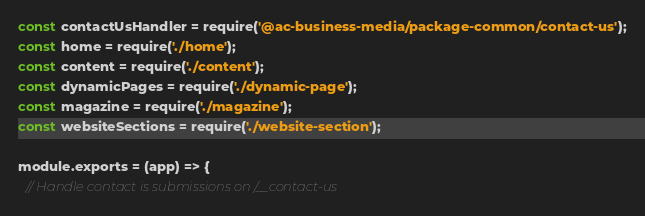<code> <loc_0><loc_0><loc_500><loc_500><_JavaScript_>const contactUsHandler = require('@ac-business-media/package-common/contact-us');
const home = require('./home');
const content = require('./content');
const dynamicPages = require('./dynamic-page');
const magazine = require('./magazine');
const websiteSections = require('./website-section');

module.exports = (app) => {
  // Handle contact is submissions on /__contact-us</code> 